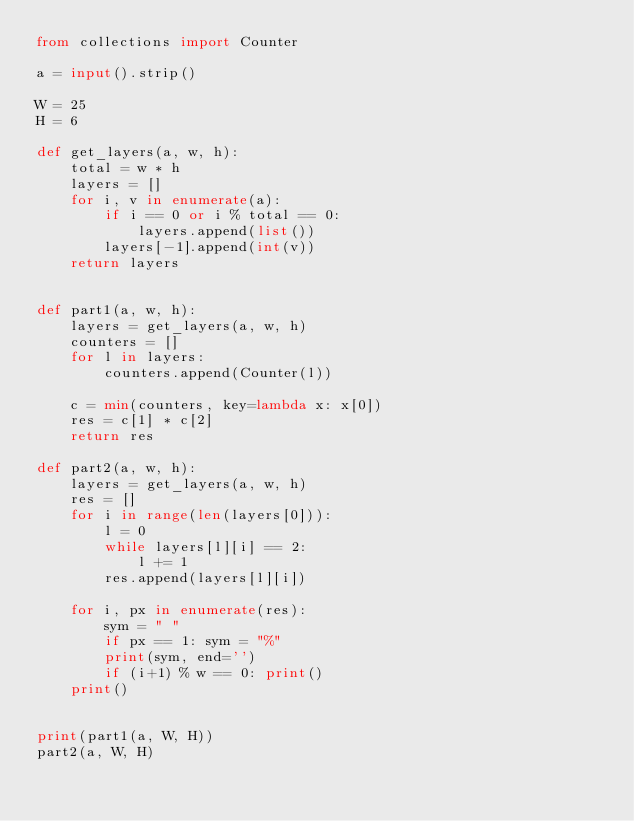Convert code to text. <code><loc_0><loc_0><loc_500><loc_500><_Python_>from collections import Counter

a = input().strip()

W = 25
H = 6

def get_layers(a, w, h):
    total = w * h
    layers = []
    for i, v in enumerate(a):
        if i == 0 or i % total == 0:
            layers.append(list())
        layers[-1].append(int(v))
    return layers


def part1(a, w, h):
    layers = get_layers(a, w, h)
    counters = []
    for l in layers:
        counters.append(Counter(l))

    c = min(counters, key=lambda x: x[0])
    res = c[1] * c[2]
    return res

def part2(a, w, h):
    layers = get_layers(a, w, h)
    res = []
    for i in range(len(layers[0])):
        l = 0
        while layers[l][i] == 2:
            l += 1
        res.append(layers[l][i])

    for i, px in enumerate(res):
        sym = " "
        if px == 1: sym = "%"
        print(sym, end='')
        if (i+1) % w == 0: print()
    print()


print(part1(a, W, H))
part2(a, W, H)
</code> 